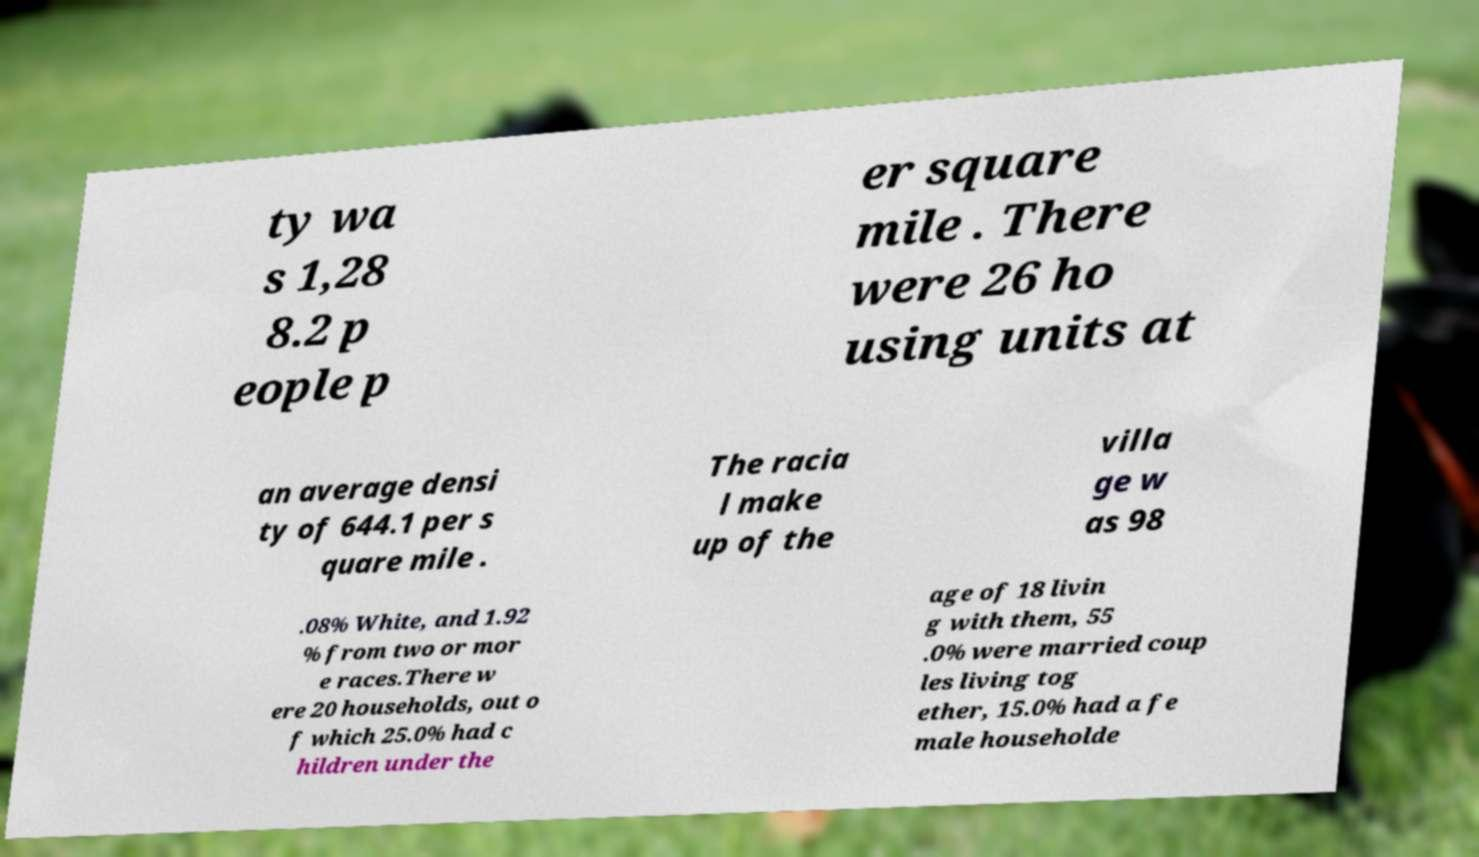Could you extract and type out the text from this image? ty wa s 1,28 8.2 p eople p er square mile . There were 26 ho using units at an average densi ty of 644.1 per s quare mile . The racia l make up of the villa ge w as 98 .08% White, and 1.92 % from two or mor e races.There w ere 20 households, out o f which 25.0% had c hildren under the age of 18 livin g with them, 55 .0% were married coup les living tog ether, 15.0% had a fe male householde 